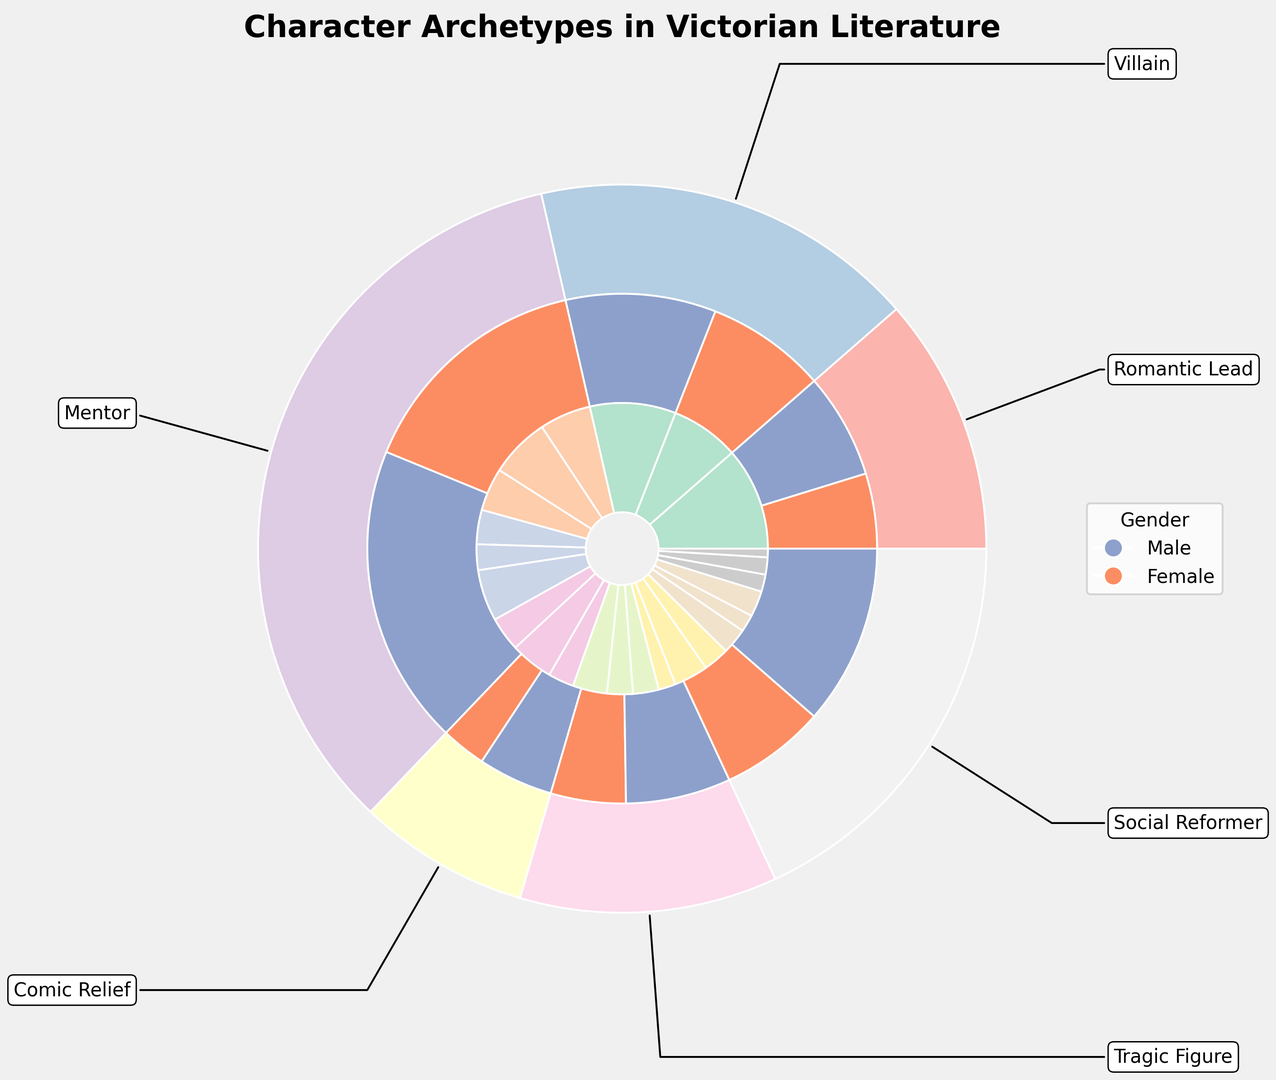What are the percentages of male and female 'Romantic Lead' characters combined? To find this, we add the percentages for each subtype within the 'Romantic Lead' category, separated by gender. For males (Brooding Hero and Charming Gentleman): 12% + 8% = 20%. For females (Spirited Heroine and Innocent Maiden): 10% + 6% = 16%. So combined, it's 20% + 16% = 36%.
Answer: 36% Which gender has a higher percentage of 'Villain' characters, and by how much? First, calculate the total percentage for male villains by adding Cruel Aristocrat (7%) and Criminal Mastermind (5%), resulting in 12%. For female villains, add Femme Fatale (4%) and Scheming Social Climber (3%), resulting in 7%. The difference between male and female villains is 12% - 7% = 5%.
Answer: Male by 5% What is the most common subtype of 'Mentor' for male characters? Looking at the figure, the male subtypes within 'Mentor' are Wise Older Man (6%) and Eccentric Professor (4%). The most common type is therefore 'Wise Older Man'.
Answer: Wise Older Man What is the total percentage of 'Comic Relief' characters? Sum up the percentages for each subtype within the 'Comic Relief' category: 
- Bumbling Servant (4%)
- Witty Dandy (3%)
- Gossipy Spinster (3%)
- Mischievous Young Girl (2%). 
The total is 4% + 3% + 3% + 2% = 12%.
Answer: 12% What fraction of 'Tragic Figure' subtypes is composed of female characters? Calculate the total percentage for 'Tragic Figure' (4% + 3% + 3% + 2% = 12%). For females: Fallen Woman (3%) and Consumptive Beauty (2%), resulting in 5%. The fraction is therefore 5%/12%.
Answer: 5/12 Which 'Social Reformer' subtype has the lowest percentage, and what is that percentage? Review the subtypes within 'Social Reformer' to find the smallest percentage: 
- Crusading Journalist (3%)
- Idealistic Clergyman (2%)
- Charitable Lady (2%)
- Progressive Activist (1%).
The 'Progressive Activist' has the lowest percentage.
Answer: Progressive Activist, 1% How does the percentage of male 'Romantic Lead' characters compare to the percentage of male 'Social Reformer' characters? Calculate the total percentage for male 'Romantic Leads' (Brooding Hero and Charming Gentleman): 12% + 8% = 20%. For male 'Social Reformers' (Crusading Journalist and Idealistic Clergyman): 3% + 2% = 5%. The male 'Romantic Leads' have a higher percentage by 20% - 5% = 15%.
Answer: 15% What is the combined percentage of female 'Villain' and 'Comic Relief' characters? Add the percentages of each subtype within 'Villain' (Femme Fatale and Scheming Social Climber: 4% + 3% = 7%) and 'Comic Relief' (Gossipy Spinster and Mischievous Young Girl: 3% + 2% = 5%). Combined, this is 7% + 5% = 12%.
Answer: 12% 